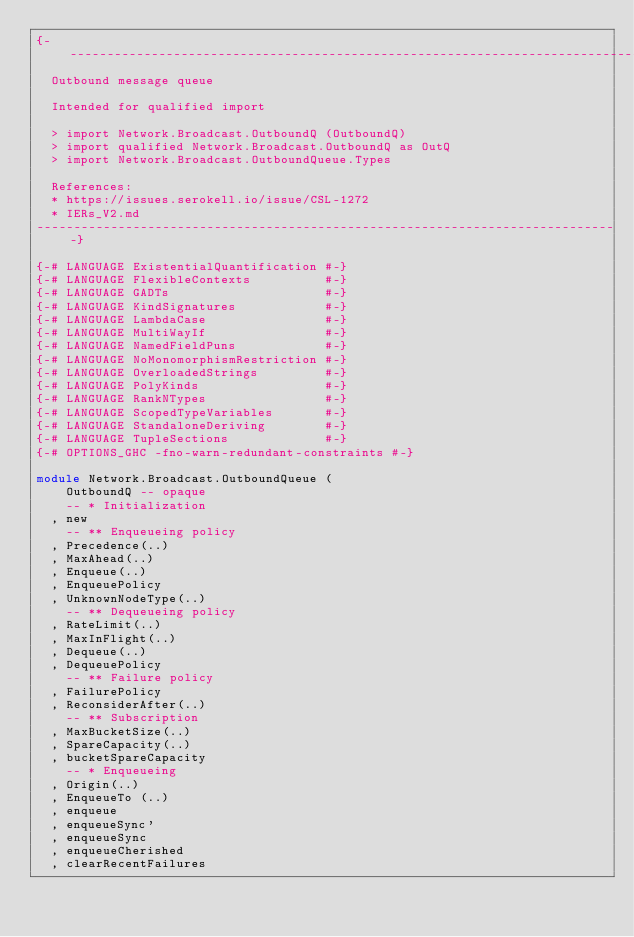<code> <loc_0><loc_0><loc_500><loc_500><_Haskell_>{-------------------------------------------------------------------------------
  Outbound message queue

  Intended for qualified import

  > import Network.Broadcast.OutboundQ (OutboundQ)
  > import qualified Network.Broadcast.OutboundQ as OutQ
  > import Network.Broadcast.OutboundQueue.Types

  References:
  * https://issues.serokell.io/issue/CSL-1272
  * IERs_V2.md
-------------------------------------------------------------------------------}

{-# LANGUAGE ExistentialQuantification #-}
{-# LANGUAGE FlexibleContexts          #-}
{-# LANGUAGE GADTs                     #-}
{-# LANGUAGE KindSignatures            #-}
{-# LANGUAGE LambdaCase                #-}
{-# LANGUAGE MultiWayIf                #-}
{-# LANGUAGE NamedFieldPuns            #-}
{-# LANGUAGE NoMonomorphismRestriction #-}
{-# LANGUAGE OverloadedStrings         #-}
{-# LANGUAGE PolyKinds                 #-}
{-# LANGUAGE RankNTypes                #-}
{-# LANGUAGE ScopedTypeVariables       #-}
{-# LANGUAGE StandaloneDeriving        #-}
{-# LANGUAGE TupleSections             #-}
{-# OPTIONS_GHC -fno-warn-redundant-constraints #-}

module Network.Broadcast.OutboundQueue (
    OutboundQ -- opaque
    -- * Initialization
  , new
    -- ** Enqueueing policy
  , Precedence(..)
  , MaxAhead(..)
  , Enqueue(..)
  , EnqueuePolicy
  , UnknownNodeType(..)
    -- ** Dequeueing policy
  , RateLimit(..)
  , MaxInFlight(..)
  , Dequeue(..)
  , DequeuePolicy
    -- ** Failure policy
  , FailurePolicy
  , ReconsiderAfter(..)
    -- ** Subscription
  , MaxBucketSize(..)
  , SpareCapacity(..)
  , bucketSpareCapacity
    -- * Enqueueing
  , Origin(..)
  , EnqueueTo (..)
  , enqueue
  , enqueueSync'
  , enqueueSync
  , enqueueCherished
  , clearRecentFailures</code> 